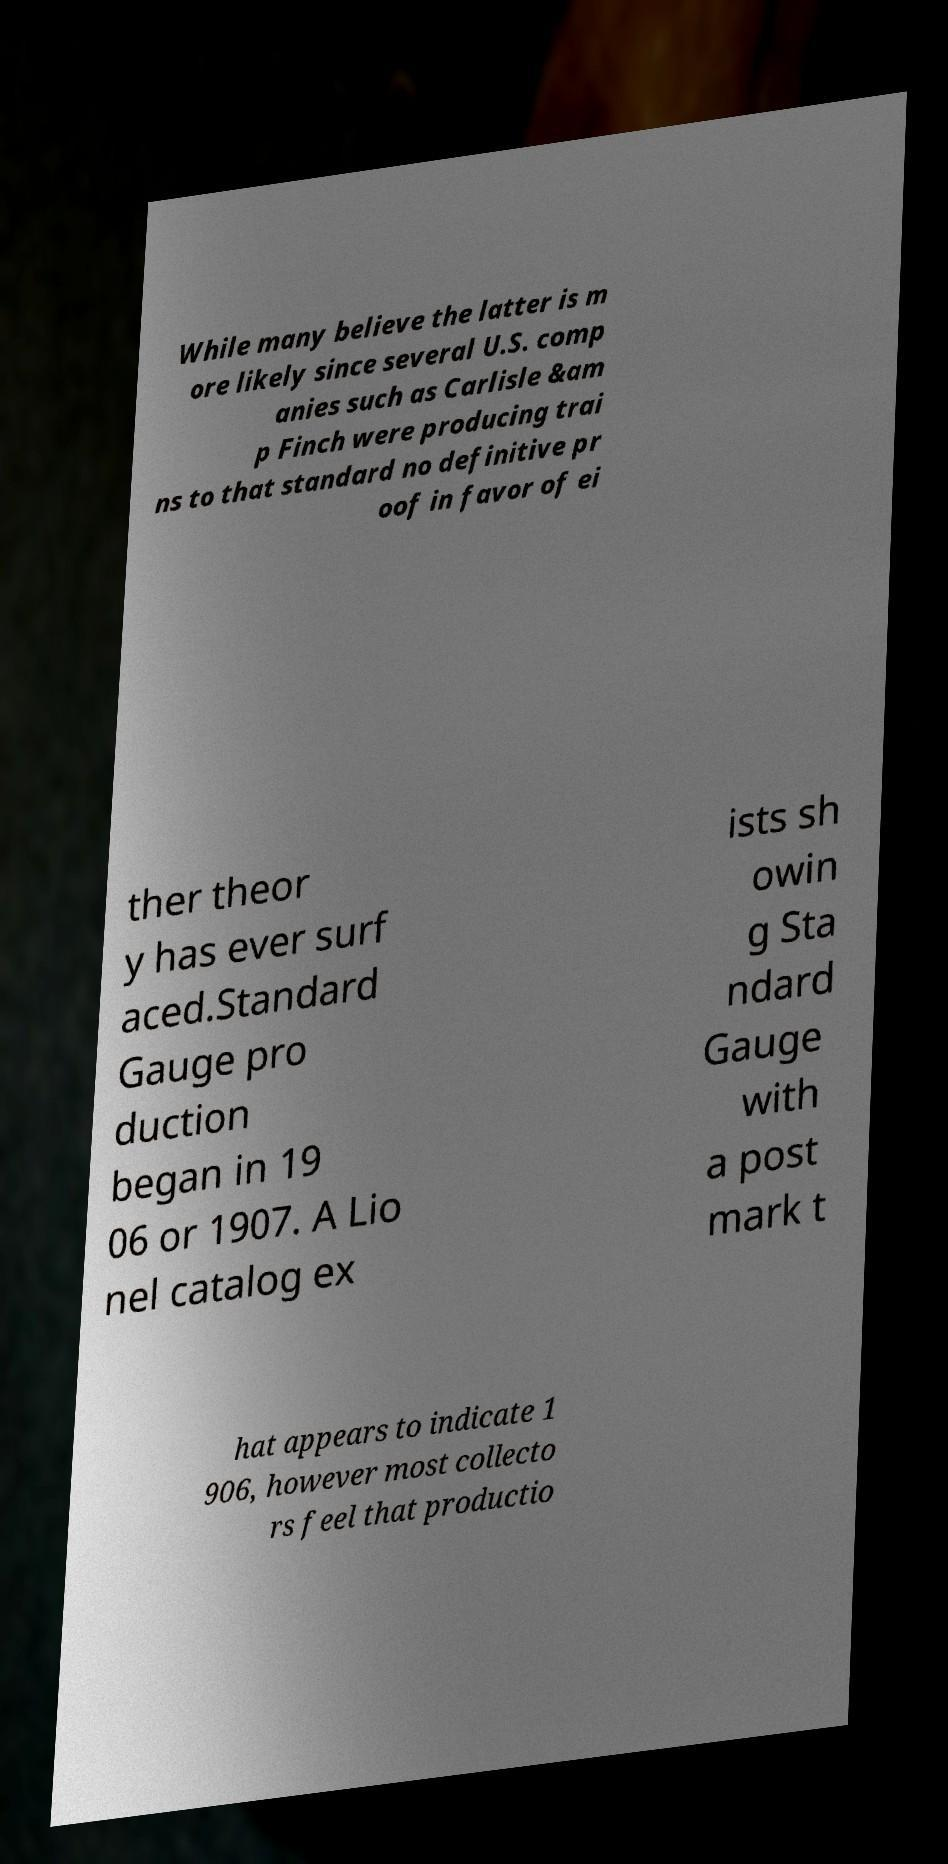Could you extract and type out the text from this image? While many believe the latter is m ore likely since several U.S. comp anies such as Carlisle &am p Finch were producing trai ns to that standard no definitive pr oof in favor of ei ther theor y has ever surf aced.Standard Gauge pro duction began in 19 06 or 1907. A Lio nel catalog ex ists sh owin g Sta ndard Gauge with a post mark t hat appears to indicate 1 906, however most collecto rs feel that productio 